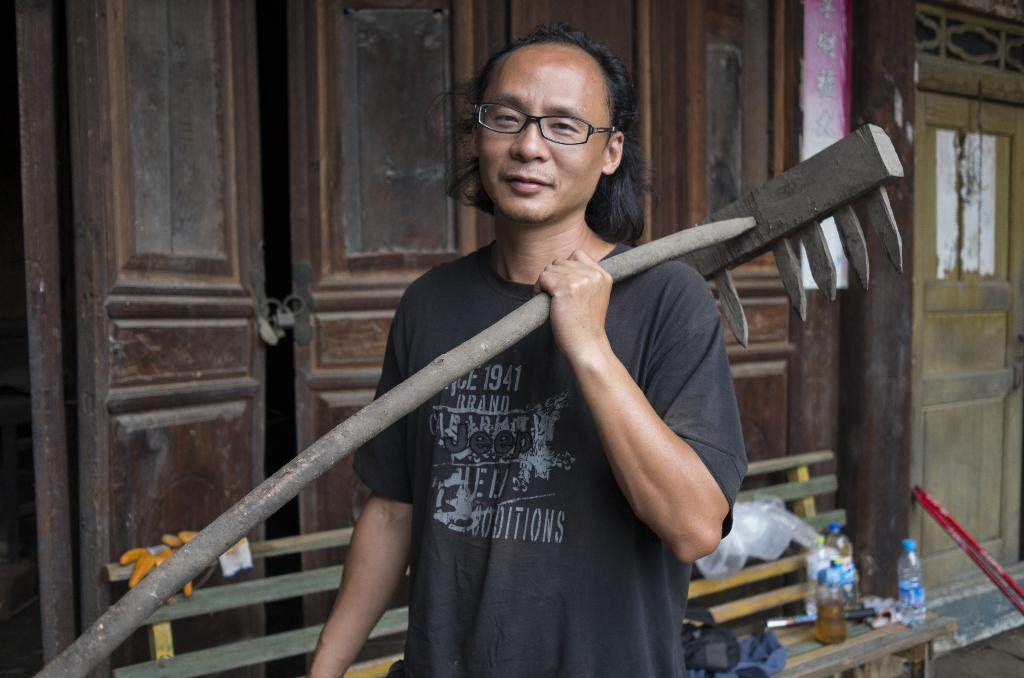What is the man in the image holding? The man is holding a tool. Can you describe the man's appearance in the image? The man is wearing spectacles. What can be seen in the background of the image? There is a door, a bench, and bottles in the background of the image. What type of hat is the man wearing in the image? There is no hat present in the image; the man is wearing spectacles. What game is the man playing with the tool in the image? There is no game being played in the image; the man is simply holding a tool. 